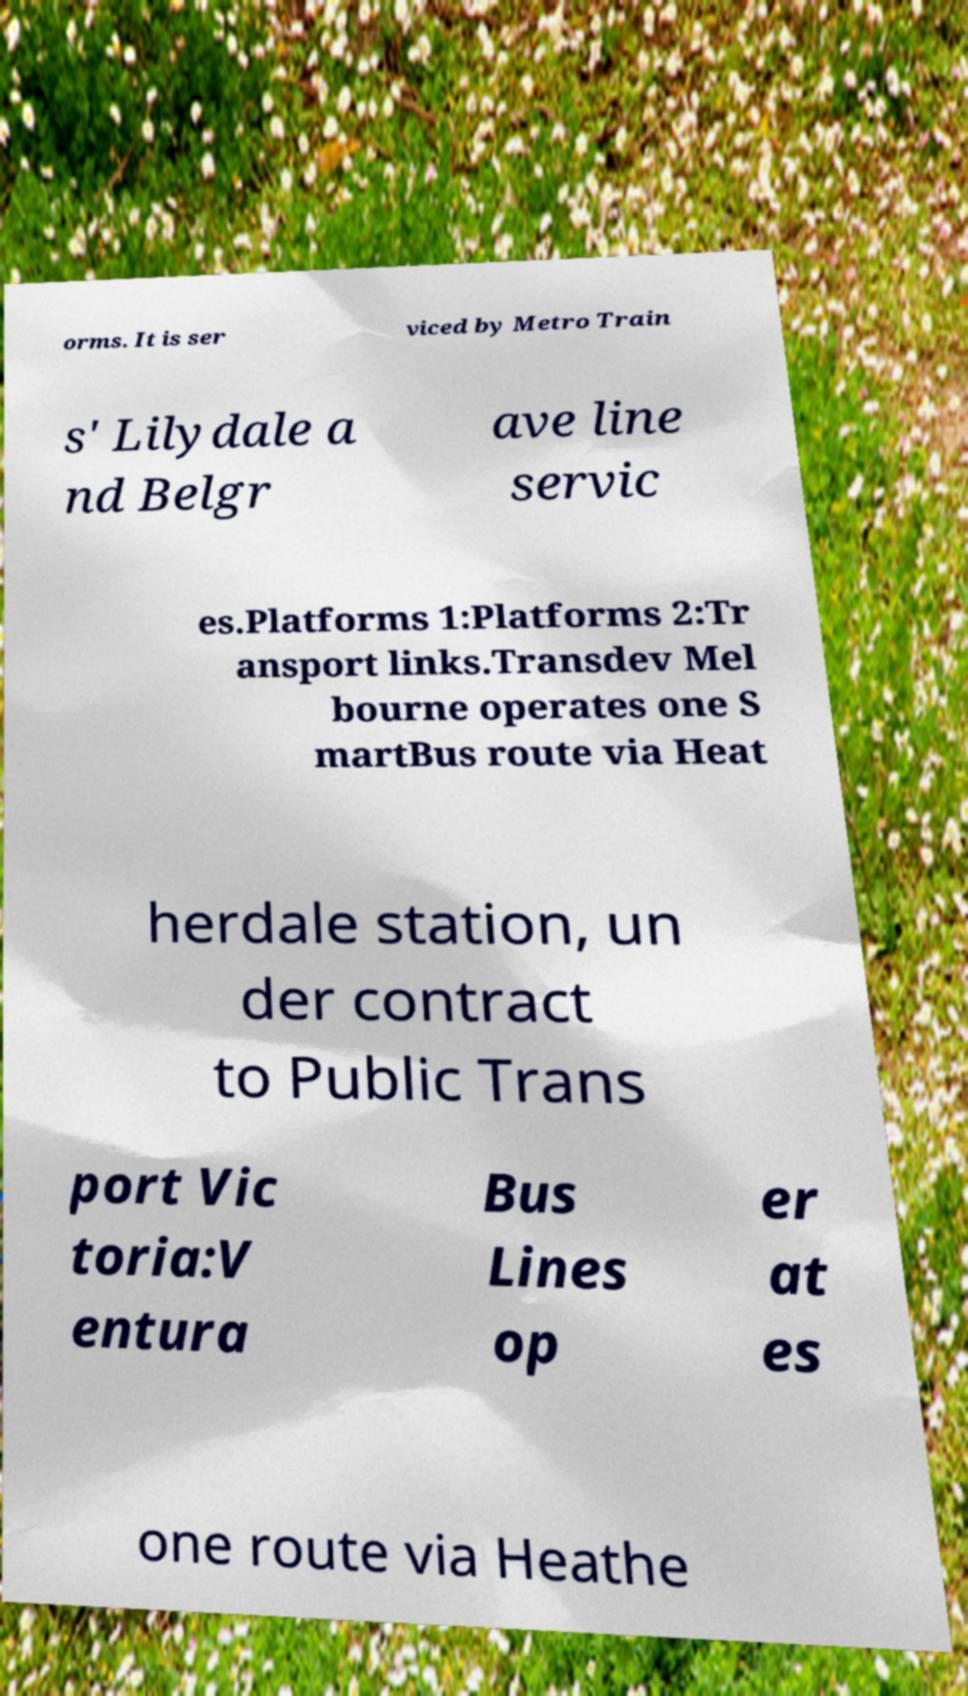I need the written content from this picture converted into text. Can you do that? orms. It is ser viced by Metro Train s' Lilydale a nd Belgr ave line servic es.Platforms 1:Platforms 2:Tr ansport links.Transdev Mel bourne operates one S martBus route via Heat herdale station, un der contract to Public Trans port Vic toria:V entura Bus Lines op er at es one route via Heathe 